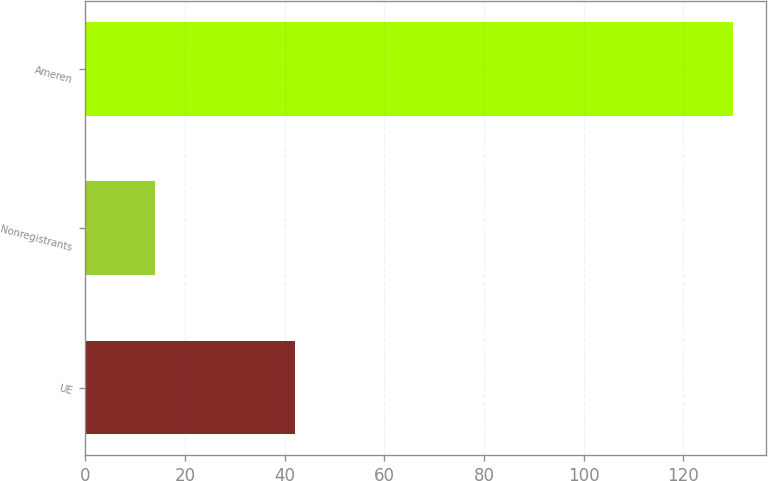Convert chart. <chart><loc_0><loc_0><loc_500><loc_500><bar_chart><fcel>UE<fcel>Nonregistrants<fcel>Ameren<nl><fcel>42<fcel>14<fcel>130<nl></chart> 